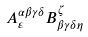Convert formula to latex. <formula><loc_0><loc_0><loc_500><loc_500>A ^ { \alpha \beta \gamma \delta } _ { \varepsilon } B ^ { \zeta } _ { \beta \gamma \delta \eta }</formula> 